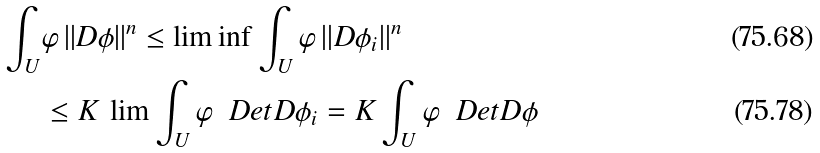Convert formula to latex. <formula><loc_0><loc_0><loc_500><loc_500>\int _ { U } & \varphi \, | | D \phi | | ^ { n } \leq \liminf \int _ { U } \varphi \, | | D \phi _ { i } | | ^ { n } \\ & \leq K \, \lim \int _ { U } \varphi \, \ D e t { D \phi _ { i } } = K \int _ { U } \varphi \, \ D e t { D \phi }</formula> 